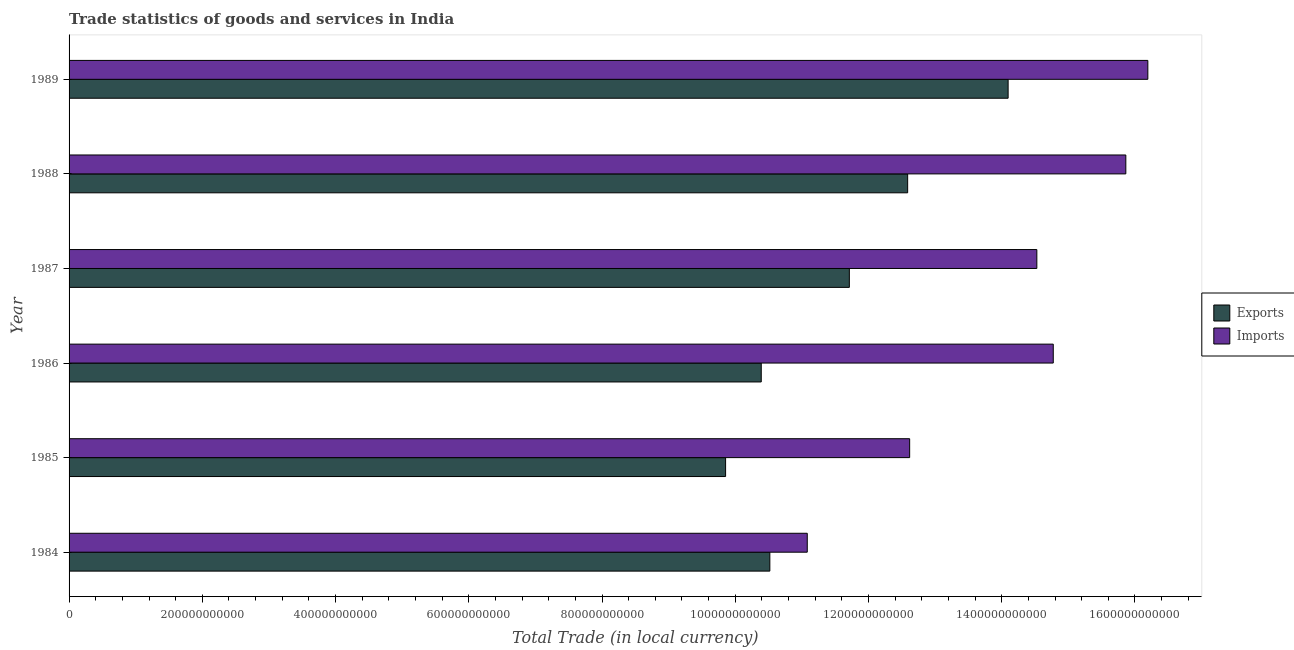How many different coloured bars are there?
Provide a short and direct response. 2. How many groups of bars are there?
Ensure brevity in your answer.  6. Are the number of bars on each tick of the Y-axis equal?
Your answer should be very brief. Yes. How many bars are there on the 6th tick from the top?
Ensure brevity in your answer.  2. What is the label of the 5th group of bars from the top?
Ensure brevity in your answer.  1985. In how many cases, is the number of bars for a given year not equal to the number of legend labels?
Your response must be concise. 0. What is the export of goods and services in 1985?
Give a very brief answer. 9.85e+11. Across all years, what is the maximum imports of goods and services?
Offer a very short reply. 1.62e+12. Across all years, what is the minimum export of goods and services?
Your answer should be compact. 9.85e+11. In which year was the imports of goods and services minimum?
Give a very brief answer. 1984. What is the total imports of goods and services in the graph?
Provide a short and direct response. 8.51e+12. What is the difference between the export of goods and services in 1985 and that in 1988?
Your response must be concise. -2.73e+11. What is the difference between the export of goods and services in 1986 and the imports of goods and services in 1985?
Your response must be concise. -2.23e+11. What is the average export of goods and services per year?
Keep it short and to the point. 1.15e+12. In the year 1985, what is the difference between the export of goods and services and imports of goods and services?
Offer a terse response. -2.76e+11. In how many years, is the imports of goods and services greater than 1040000000000 LCU?
Your response must be concise. 6. What is the ratio of the export of goods and services in 1988 to that in 1989?
Provide a succinct answer. 0.89. Is the imports of goods and services in 1984 less than that in 1985?
Offer a terse response. Yes. Is the difference between the imports of goods and services in 1987 and 1989 greater than the difference between the export of goods and services in 1987 and 1989?
Keep it short and to the point. Yes. What is the difference between the highest and the second highest export of goods and services?
Ensure brevity in your answer.  1.51e+11. What is the difference between the highest and the lowest imports of goods and services?
Give a very brief answer. 5.11e+11. In how many years, is the imports of goods and services greater than the average imports of goods and services taken over all years?
Offer a terse response. 4. What does the 2nd bar from the top in 1984 represents?
Offer a terse response. Exports. What does the 1st bar from the bottom in 1986 represents?
Offer a terse response. Exports. How many bars are there?
Offer a terse response. 12. How many years are there in the graph?
Ensure brevity in your answer.  6. What is the difference between two consecutive major ticks on the X-axis?
Provide a succinct answer. 2.00e+11. Does the graph contain grids?
Your response must be concise. No. How many legend labels are there?
Your response must be concise. 2. How are the legend labels stacked?
Ensure brevity in your answer.  Vertical. What is the title of the graph?
Offer a terse response. Trade statistics of goods and services in India. Does "Taxes" appear as one of the legend labels in the graph?
Your response must be concise. No. What is the label or title of the X-axis?
Your answer should be compact. Total Trade (in local currency). What is the label or title of the Y-axis?
Offer a very short reply. Year. What is the Total Trade (in local currency) in Exports in 1984?
Ensure brevity in your answer.  1.05e+12. What is the Total Trade (in local currency) of Imports in 1984?
Give a very brief answer. 1.11e+12. What is the Total Trade (in local currency) in Exports in 1985?
Your response must be concise. 9.85e+11. What is the Total Trade (in local currency) of Imports in 1985?
Provide a succinct answer. 1.26e+12. What is the Total Trade (in local currency) of Exports in 1986?
Provide a succinct answer. 1.04e+12. What is the Total Trade (in local currency) in Imports in 1986?
Offer a terse response. 1.48e+12. What is the Total Trade (in local currency) in Exports in 1987?
Provide a succinct answer. 1.17e+12. What is the Total Trade (in local currency) of Imports in 1987?
Provide a short and direct response. 1.45e+12. What is the Total Trade (in local currency) of Exports in 1988?
Make the answer very short. 1.26e+12. What is the Total Trade (in local currency) of Imports in 1988?
Ensure brevity in your answer.  1.59e+12. What is the Total Trade (in local currency) in Exports in 1989?
Your answer should be compact. 1.41e+12. What is the Total Trade (in local currency) in Imports in 1989?
Provide a succinct answer. 1.62e+12. Across all years, what is the maximum Total Trade (in local currency) in Exports?
Your answer should be compact. 1.41e+12. Across all years, what is the maximum Total Trade (in local currency) of Imports?
Offer a terse response. 1.62e+12. Across all years, what is the minimum Total Trade (in local currency) in Exports?
Your answer should be very brief. 9.85e+11. Across all years, what is the minimum Total Trade (in local currency) of Imports?
Offer a very short reply. 1.11e+12. What is the total Total Trade (in local currency) in Exports in the graph?
Your answer should be very brief. 6.92e+12. What is the total Total Trade (in local currency) of Imports in the graph?
Provide a succinct answer. 8.51e+12. What is the difference between the Total Trade (in local currency) of Exports in 1984 and that in 1985?
Make the answer very short. 6.64e+1. What is the difference between the Total Trade (in local currency) of Imports in 1984 and that in 1985?
Keep it short and to the point. -1.54e+11. What is the difference between the Total Trade (in local currency) of Exports in 1984 and that in 1986?
Your answer should be very brief. 1.29e+1. What is the difference between the Total Trade (in local currency) in Imports in 1984 and that in 1986?
Ensure brevity in your answer.  -3.69e+11. What is the difference between the Total Trade (in local currency) of Exports in 1984 and that in 1987?
Provide a short and direct response. -1.19e+11. What is the difference between the Total Trade (in local currency) in Imports in 1984 and that in 1987?
Give a very brief answer. -3.45e+11. What is the difference between the Total Trade (in local currency) of Exports in 1984 and that in 1988?
Ensure brevity in your answer.  -2.07e+11. What is the difference between the Total Trade (in local currency) of Imports in 1984 and that in 1988?
Your response must be concise. -4.78e+11. What is the difference between the Total Trade (in local currency) of Exports in 1984 and that in 1989?
Keep it short and to the point. -3.58e+11. What is the difference between the Total Trade (in local currency) in Imports in 1984 and that in 1989?
Your answer should be very brief. -5.11e+11. What is the difference between the Total Trade (in local currency) in Exports in 1985 and that in 1986?
Make the answer very short. -5.35e+1. What is the difference between the Total Trade (in local currency) in Imports in 1985 and that in 1986?
Your answer should be compact. -2.16e+11. What is the difference between the Total Trade (in local currency) in Exports in 1985 and that in 1987?
Your response must be concise. -1.86e+11. What is the difference between the Total Trade (in local currency) of Imports in 1985 and that in 1987?
Keep it short and to the point. -1.91e+11. What is the difference between the Total Trade (in local currency) in Exports in 1985 and that in 1988?
Offer a very short reply. -2.73e+11. What is the difference between the Total Trade (in local currency) in Imports in 1985 and that in 1988?
Offer a terse response. -3.24e+11. What is the difference between the Total Trade (in local currency) of Exports in 1985 and that in 1989?
Provide a succinct answer. -4.24e+11. What is the difference between the Total Trade (in local currency) of Imports in 1985 and that in 1989?
Provide a short and direct response. -3.58e+11. What is the difference between the Total Trade (in local currency) of Exports in 1986 and that in 1987?
Make the answer very short. -1.32e+11. What is the difference between the Total Trade (in local currency) in Imports in 1986 and that in 1987?
Offer a very short reply. 2.46e+1. What is the difference between the Total Trade (in local currency) in Exports in 1986 and that in 1988?
Your response must be concise. -2.20e+11. What is the difference between the Total Trade (in local currency) in Imports in 1986 and that in 1988?
Ensure brevity in your answer.  -1.09e+11. What is the difference between the Total Trade (in local currency) of Exports in 1986 and that in 1989?
Your answer should be compact. -3.71e+11. What is the difference between the Total Trade (in local currency) of Imports in 1986 and that in 1989?
Offer a very short reply. -1.42e+11. What is the difference between the Total Trade (in local currency) of Exports in 1987 and that in 1988?
Your response must be concise. -8.75e+1. What is the difference between the Total Trade (in local currency) of Imports in 1987 and that in 1988?
Offer a terse response. -1.34e+11. What is the difference between the Total Trade (in local currency) in Exports in 1987 and that in 1989?
Provide a succinct answer. -2.38e+11. What is the difference between the Total Trade (in local currency) of Imports in 1987 and that in 1989?
Your answer should be very brief. -1.67e+11. What is the difference between the Total Trade (in local currency) of Exports in 1988 and that in 1989?
Your answer should be compact. -1.51e+11. What is the difference between the Total Trade (in local currency) in Imports in 1988 and that in 1989?
Give a very brief answer. -3.31e+1. What is the difference between the Total Trade (in local currency) in Exports in 1984 and the Total Trade (in local currency) in Imports in 1985?
Provide a short and direct response. -2.10e+11. What is the difference between the Total Trade (in local currency) of Exports in 1984 and the Total Trade (in local currency) of Imports in 1986?
Offer a very short reply. -4.25e+11. What is the difference between the Total Trade (in local currency) in Exports in 1984 and the Total Trade (in local currency) in Imports in 1987?
Make the answer very short. -4.01e+11. What is the difference between the Total Trade (in local currency) of Exports in 1984 and the Total Trade (in local currency) of Imports in 1988?
Provide a short and direct response. -5.34e+11. What is the difference between the Total Trade (in local currency) in Exports in 1984 and the Total Trade (in local currency) in Imports in 1989?
Offer a terse response. -5.67e+11. What is the difference between the Total Trade (in local currency) of Exports in 1985 and the Total Trade (in local currency) of Imports in 1986?
Ensure brevity in your answer.  -4.92e+11. What is the difference between the Total Trade (in local currency) in Exports in 1985 and the Total Trade (in local currency) in Imports in 1987?
Keep it short and to the point. -4.67e+11. What is the difference between the Total Trade (in local currency) of Exports in 1985 and the Total Trade (in local currency) of Imports in 1988?
Ensure brevity in your answer.  -6.01e+11. What is the difference between the Total Trade (in local currency) of Exports in 1985 and the Total Trade (in local currency) of Imports in 1989?
Make the answer very short. -6.34e+11. What is the difference between the Total Trade (in local currency) in Exports in 1986 and the Total Trade (in local currency) in Imports in 1987?
Your response must be concise. -4.14e+11. What is the difference between the Total Trade (in local currency) in Exports in 1986 and the Total Trade (in local currency) in Imports in 1988?
Offer a very short reply. -5.47e+11. What is the difference between the Total Trade (in local currency) in Exports in 1986 and the Total Trade (in local currency) in Imports in 1989?
Your answer should be very brief. -5.80e+11. What is the difference between the Total Trade (in local currency) in Exports in 1987 and the Total Trade (in local currency) in Imports in 1988?
Offer a terse response. -4.15e+11. What is the difference between the Total Trade (in local currency) of Exports in 1987 and the Total Trade (in local currency) of Imports in 1989?
Ensure brevity in your answer.  -4.48e+11. What is the difference between the Total Trade (in local currency) in Exports in 1988 and the Total Trade (in local currency) in Imports in 1989?
Offer a terse response. -3.61e+11. What is the average Total Trade (in local currency) of Exports per year?
Keep it short and to the point. 1.15e+12. What is the average Total Trade (in local currency) in Imports per year?
Provide a short and direct response. 1.42e+12. In the year 1984, what is the difference between the Total Trade (in local currency) of Exports and Total Trade (in local currency) of Imports?
Offer a terse response. -5.62e+1. In the year 1985, what is the difference between the Total Trade (in local currency) of Exports and Total Trade (in local currency) of Imports?
Give a very brief answer. -2.76e+11. In the year 1986, what is the difference between the Total Trade (in local currency) in Exports and Total Trade (in local currency) in Imports?
Keep it short and to the point. -4.38e+11. In the year 1987, what is the difference between the Total Trade (in local currency) in Exports and Total Trade (in local currency) in Imports?
Offer a very short reply. -2.81e+11. In the year 1988, what is the difference between the Total Trade (in local currency) of Exports and Total Trade (in local currency) of Imports?
Your response must be concise. -3.27e+11. In the year 1989, what is the difference between the Total Trade (in local currency) of Exports and Total Trade (in local currency) of Imports?
Make the answer very short. -2.10e+11. What is the ratio of the Total Trade (in local currency) in Exports in 1984 to that in 1985?
Offer a very short reply. 1.07. What is the ratio of the Total Trade (in local currency) of Imports in 1984 to that in 1985?
Keep it short and to the point. 0.88. What is the ratio of the Total Trade (in local currency) of Exports in 1984 to that in 1986?
Your response must be concise. 1.01. What is the ratio of the Total Trade (in local currency) of Imports in 1984 to that in 1986?
Give a very brief answer. 0.75. What is the ratio of the Total Trade (in local currency) of Exports in 1984 to that in 1987?
Your response must be concise. 0.9. What is the ratio of the Total Trade (in local currency) in Imports in 1984 to that in 1987?
Your answer should be very brief. 0.76. What is the ratio of the Total Trade (in local currency) of Exports in 1984 to that in 1988?
Your response must be concise. 0.84. What is the ratio of the Total Trade (in local currency) in Imports in 1984 to that in 1988?
Ensure brevity in your answer.  0.7. What is the ratio of the Total Trade (in local currency) of Exports in 1984 to that in 1989?
Offer a terse response. 0.75. What is the ratio of the Total Trade (in local currency) in Imports in 1984 to that in 1989?
Offer a very short reply. 0.68. What is the ratio of the Total Trade (in local currency) of Exports in 1985 to that in 1986?
Offer a terse response. 0.95. What is the ratio of the Total Trade (in local currency) of Imports in 1985 to that in 1986?
Offer a terse response. 0.85. What is the ratio of the Total Trade (in local currency) of Exports in 1985 to that in 1987?
Keep it short and to the point. 0.84. What is the ratio of the Total Trade (in local currency) of Imports in 1985 to that in 1987?
Ensure brevity in your answer.  0.87. What is the ratio of the Total Trade (in local currency) in Exports in 1985 to that in 1988?
Offer a terse response. 0.78. What is the ratio of the Total Trade (in local currency) in Imports in 1985 to that in 1988?
Provide a short and direct response. 0.8. What is the ratio of the Total Trade (in local currency) of Exports in 1985 to that in 1989?
Provide a succinct answer. 0.7. What is the ratio of the Total Trade (in local currency) in Imports in 1985 to that in 1989?
Make the answer very short. 0.78. What is the ratio of the Total Trade (in local currency) of Exports in 1986 to that in 1987?
Keep it short and to the point. 0.89. What is the ratio of the Total Trade (in local currency) of Imports in 1986 to that in 1987?
Your response must be concise. 1.02. What is the ratio of the Total Trade (in local currency) in Exports in 1986 to that in 1988?
Ensure brevity in your answer.  0.83. What is the ratio of the Total Trade (in local currency) in Imports in 1986 to that in 1988?
Your answer should be compact. 0.93. What is the ratio of the Total Trade (in local currency) in Exports in 1986 to that in 1989?
Offer a terse response. 0.74. What is the ratio of the Total Trade (in local currency) in Imports in 1986 to that in 1989?
Offer a terse response. 0.91. What is the ratio of the Total Trade (in local currency) in Exports in 1987 to that in 1988?
Make the answer very short. 0.93. What is the ratio of the Total Trade (in local currency) of Imports in 1987 to that in 1988?
Give a very brief answer. 0.92. What is the ratio of the Total Trade (in local currency) in Exports in 1987 to that in 1989?
Your response must be concise. 0.83. What is the ratio of the Total Trade (in local currency) of Imports in 1987 to that in 1989?
Offer a terse response. 0.9. What is the ratio of the Total Trade (in local currency) of Exports in 1988 to that in 1989?
Ensure brevity in your answer.  0.89. What is the ratio of the Total Trade (in local currency) in Imports in 1988 to that in 1989?
Provide a short and direct response. 0.98. What is the difference between the highest and the second highest Total Trade (in local currency) in Exports?
Your response must be concise. 1.51e+11. What is the difference between the highest and the second highest Total Trade (in local currency) of Imports?
Keep it short and to the point. 3.31e+1. What is the difference between the highest and the lowest Total Trade (in local currency) of Exports?
Your answer should be very brief. 4.24e+11. What is the difference between the highest and the lowest Total Trade (in local currency) in Imports?
Provide a succinct answer. 5.11e+11. 